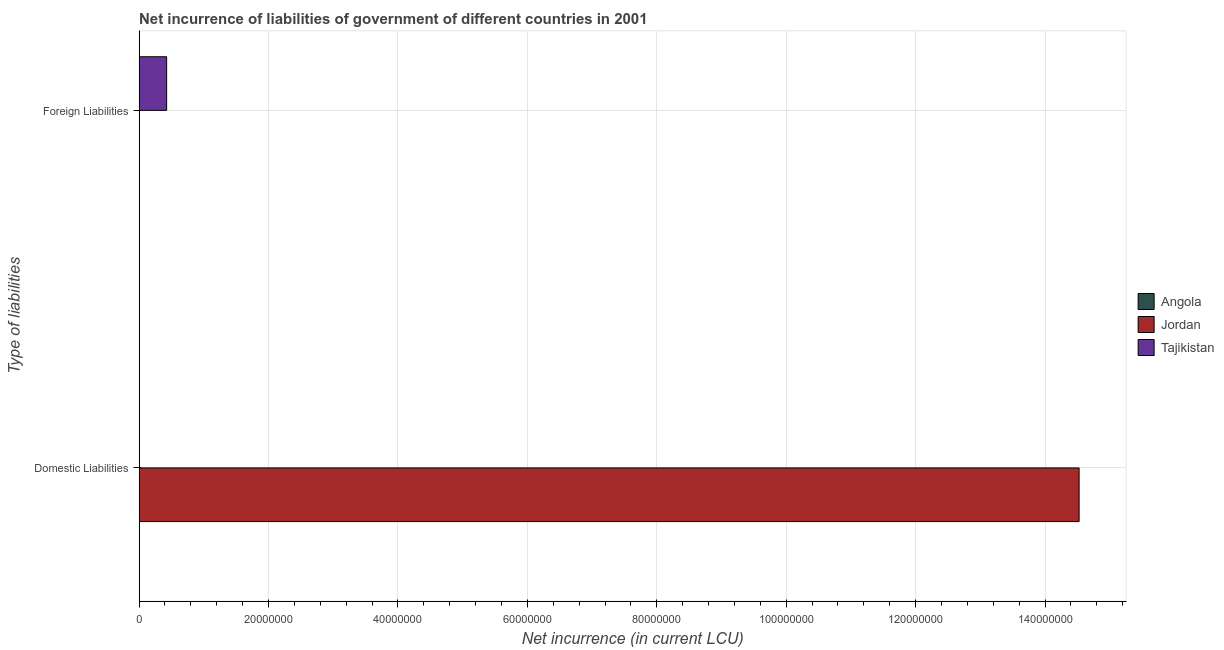Are the number of bars on each tick of the Y-axis equal?
Offer a terse response. Yes. What is the label of the 2nd group of bars from the top?
Provide a short and direct response. Domestic Liabilities. What is the net incurrence of domestic liabilities in Jordan?
Your answer should be very brief. 1.45e+08. Across all countries, what is the maximum net incurrence of domestic liabilities?
Offer a very short reply. 1.45e+08. Across all countries, what is the minimum net incurrence of domestic liabilities?
Give a very brief answer. 0. In which country was the net incurrence of domestic liabilities maximum?
Provide a succinct answer. Jordan. What is the total net incurrence of domestic liabilities in the graph?
Provide a short and direct response. 1.45e+08. What is the difference between the net incurrence of domestic liabilities in Tajikistan and the net incurrence of foreign liabilities in Jordan?
Provide a short and direct response. 0. What is the average net incurrence of foreign liabilities per country?
Your response must be concise. 1.42e+06. In how many countries, is the net incurrence of domestic liabilities greater than 48000000 LCU?
Provide a short and direct response. 1. In how many countries, is the net incurrence of domestic liabilities greater than the average net incurrence of domestic liabilities taken over all countries?
Your answer should be very brief. 1. How many bars are there?
Your answer should be compact. 2. How many countries are there in the graph?
Offer a terse response. 3. What is the difference between two consecutive major ticks on the X-axis?
Provide a succinct answer. 2.00e+07. Are the values on the major ticks of X-axis written in scientific E-notation?
Offer a terse response. No. Does the graph contain any zero values?
Provide a succinct answer. Yes. How many legend labels are there?
Ensure brevity in your answer.  3. How are the legend labels stacked?
Provide a succinct answer. Vertical. What is the title of the graph?
Give a very brief answer. Net incurrence of liabilities of government of different countries in 2001. Does "Bhutan" appear as one of the legend labels in the graph?
Offer a terse response. No. What is the label or title of the X-axis?
Your answer should be very brief. Net incurrence (in current LCU). What is the label or title of the Y-axis?
Offer a terse response. Type of liabilities. What is the Net incurrence (in current LCU) in Jordan in Domestic Liabilities?
Provide a short and direct response. 1.45e+08. What is the Net incurrence (in current LCU) of Angola in Foreign Liabilities?
Your response must be concise. 0. What is the Net incurrence (in current LCU) of Jordan in Foreign Liabilities?
Offer a very short reply. 0. What is the Net incurrence (in current LCU) of Tajikistan in Foreign Liabilities?
Make the answer very short. 4.26e+06. Across all Type of liabilities, what is the maximum Net incurrence (in current LCU) of Jordan?
Give a very brief answer. 1.45e+08. Across all Type of liabilities, what is the maximum Net incurrence (in current LCU) in Tajikistan?
Offer a very short reply. 4.26e+06. Across all Type of liabilities, what is the minimum Net incurrence (in current LCU) of Tajikistan?
Offer a very short reply. 0. What is the total Net incurrence (in current LCU) in Jordan in the graph?
Your answer should be very brief. 1.45e+08. What is the total Net incurrence (in current LCU) of Tajikistan in the graph?
Ensure brevity in your answer.  4.26e+06. What is the difference between the Net incurrence (in current LCU) in Jordan in Domestic Liabilities and the Net incurrence (in current LCU) in Tajikistan in Foreign Liabilities?
Your response must be concise. 1.41e+08. What is the average Net incurrence (in current LCU) of Angola per Type of liabilities?
Offer a terse response. 0. What is the average Net incurrence (in current LCU) of Jordan per Type of liabilities?
Your response must be concise. 7.26e+07. What is the average Net incurrence (in current LCU) of Tajikistan per Type of liabilities?
Your response must be concise. 2.13e+06. What is the difference between the highest and the lowest Net incurrence (in current LCU) in Jordan?
Keep it short and to the point. 1.45e+08. What is the difference between the highest and the lowest Net incurrence (in current LCU) in Tajikistan?
Your response must be concise. 4.26e+06. 